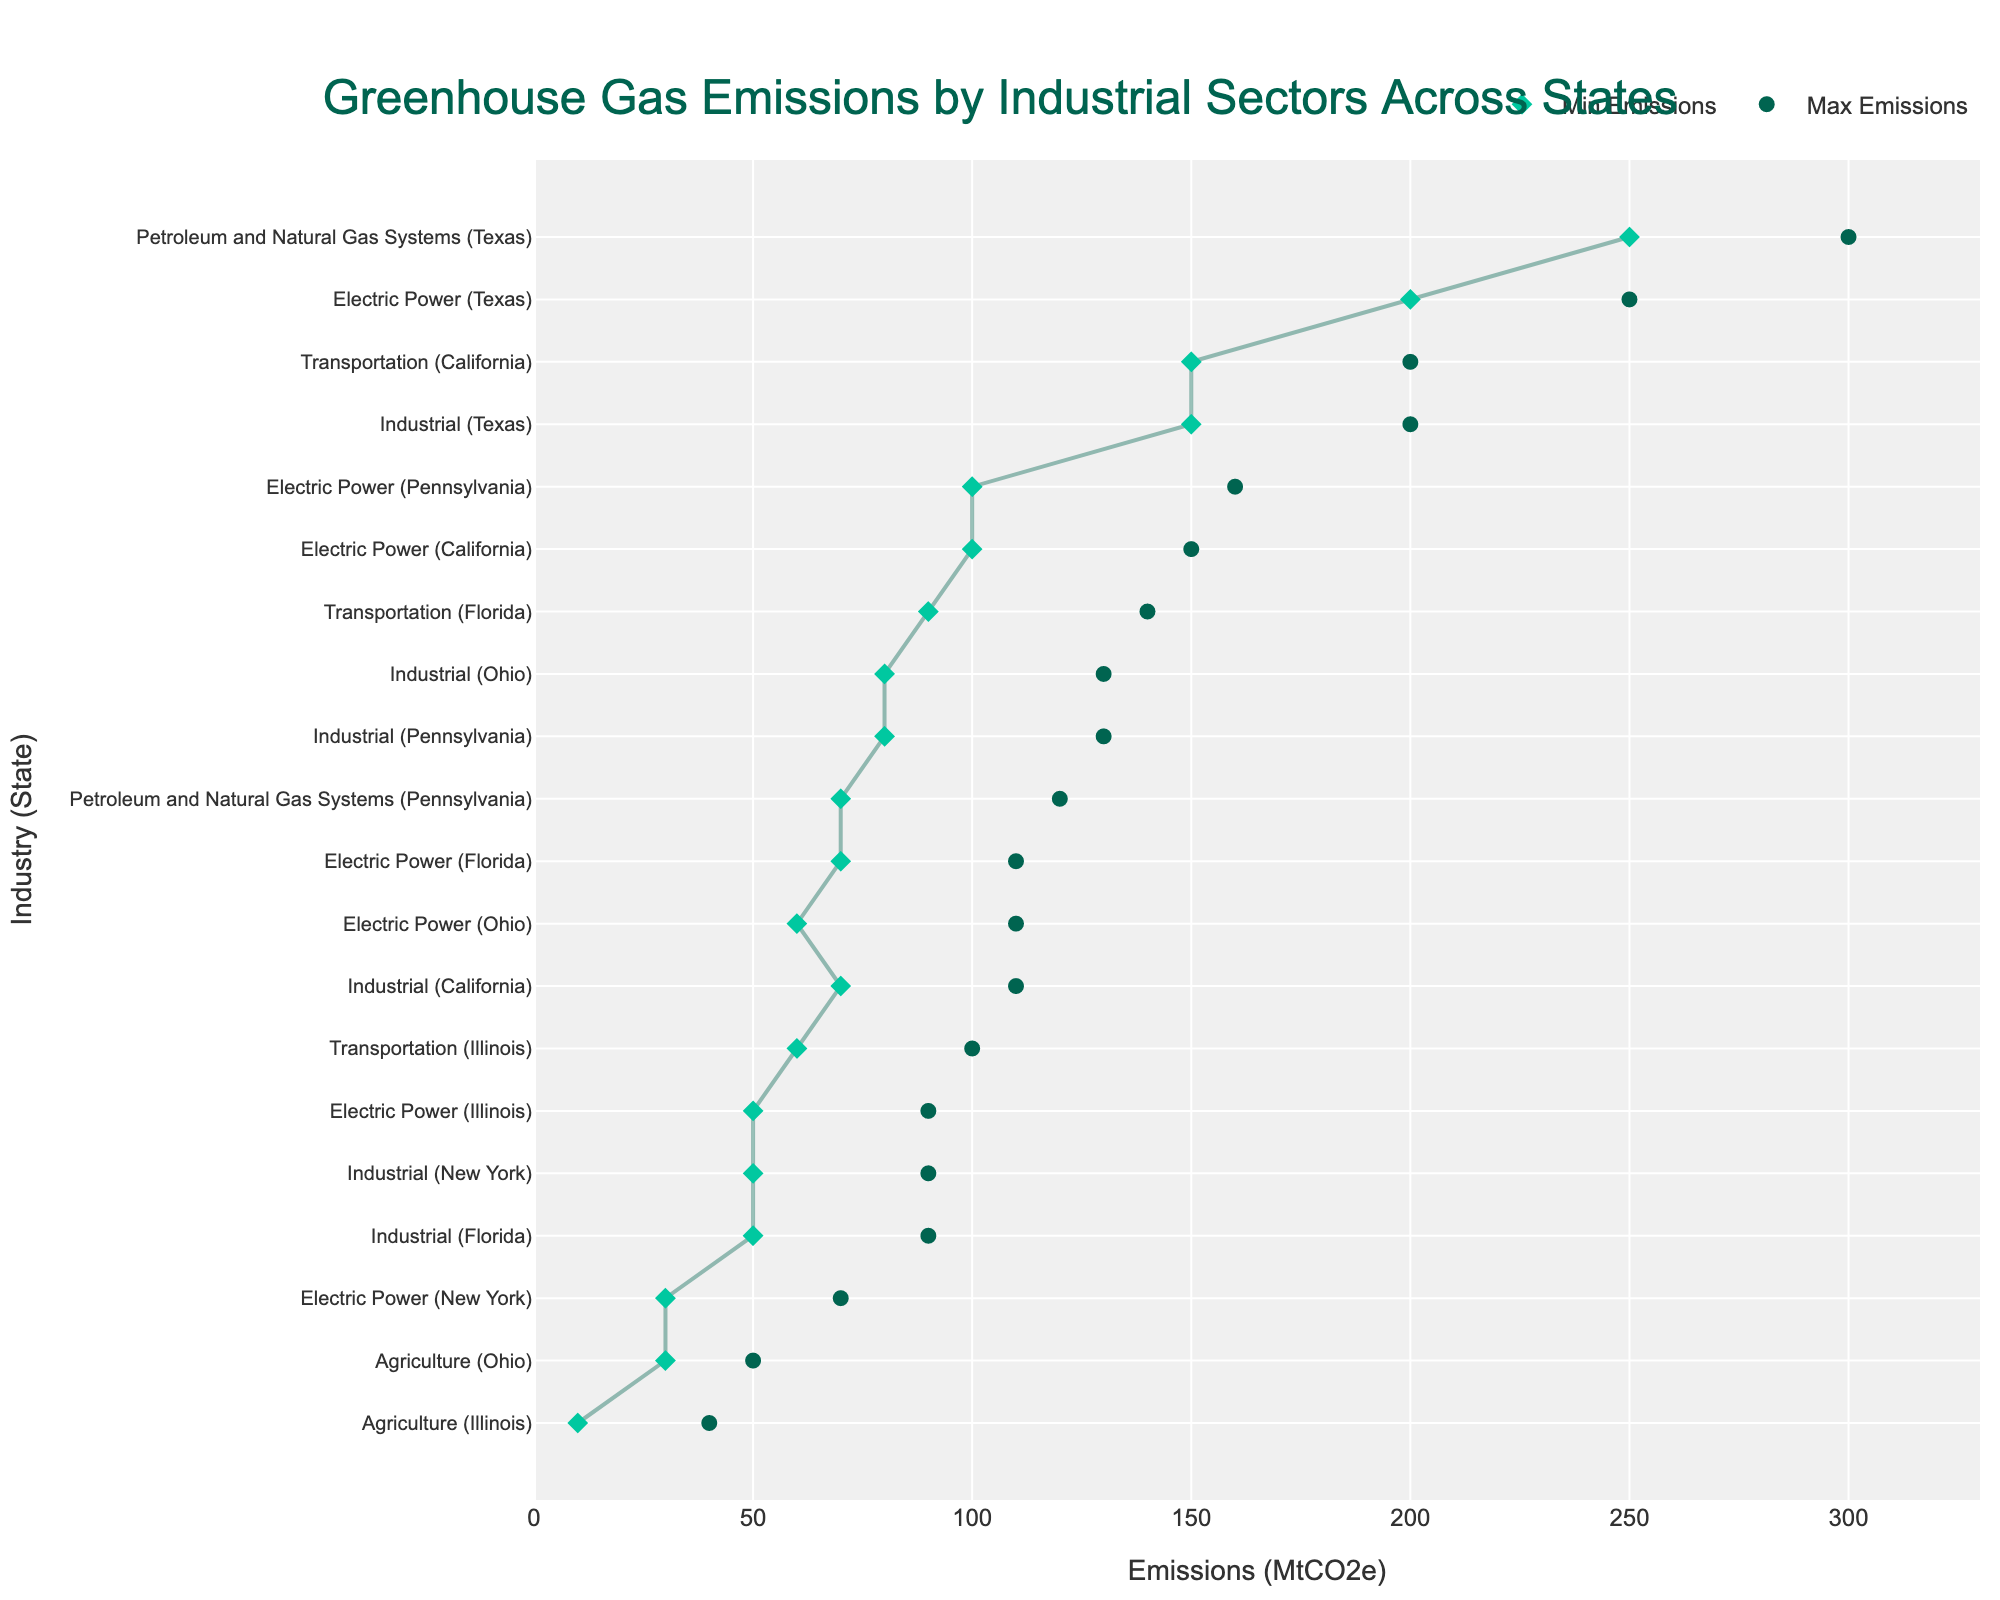What is the maximum emission for California's Transportation sector? The dot for the maximum emission of California's Transportation sector can be identified and read directly from the x-axis.
Answer: 200 MtCO2e Which state has the highest maximum emissions in any sector and what is the sector? Compare the maximum emission dots for all sectors in the figure. Texas has the highest dot in the Petroleum and Natural Gas Systems sector.
Answer: Texas, Petroleum and Natural Gas Systems What is the range of emissions for Ohio's Agriculture sector? Locate the min and max points for Ohio's Agriculture sector and calculate the difference: max (50 MtCO2e) - min (30 MtCO2e).
Answer: 20 MtCO2e How do the maximum emissions of the Electric Power sector in Florida compare to those in Ohio? Compare the top dots of the Electric Power sectors for both Florida (110 MtCO2e) and Ohio (110 MtCO2e). Both values are equal.
Answer: They are equal Which sector has the smallest minimum emissions across all states? Identify the sector with the lowest min emission dot across the entire figure. Illinois Agriculture has the smallest min emission at 10 MtCO2e.
Answer: Illinois, Agriculture What is the difference between the minimum and maximum emissions for Texas's Electric Power sector? Subtract the minimum (200 MtCO2e) from the maximum (250 MtCO2e) for Texas's Electric Power sector.
Answer: 50 MtCO2e Which industrial sector in New York has the highest range of emissions? Compare the range (max - min) for each sector in New York, Industrial: (90 - 50) 40 MtCO2e, Electric Power: (70 - 30) 40 MtCO2e. Both have maximum equal ranges.
Answer: Industrial and Electric Power What are the sectors with emissions strictly higher than the Electric Power sector in Ohio? Identify sectors whose min points are strictly higher than the Electric Power sector's max (110 MtCO2e) in Ohio: None.
Answer: None 